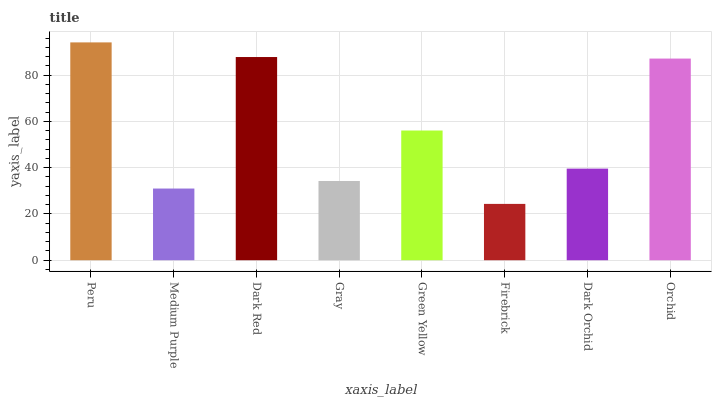Is Firebrick the minimum?
Answer yes or no. Yes. Is Peru the maximum?
Answer yes or no. Yes. Is Medium Purple the minimum?
Answer yes or no. No. Is Medium Purple the maximum?
Answer yes or no. No. Is Peru greater than Medium Purple?
Answer yes or no. Yes. Is Medium Purple less than Peru?
Answer yes or no. Yes. Is Medium Purple greater than Peru?
Answer yes or no. No. Is Peru less than Medium Purple?
Answer yes or no. No. Is Green Yellow the high median?
Answer yes or no. Yes. Is Dark Orchid the low median?
Answer yes or no. Yes. Is Dark Red the high median?
Answer yes or no. No. Is Firebrick the low median?
Answer yes or no. No. 